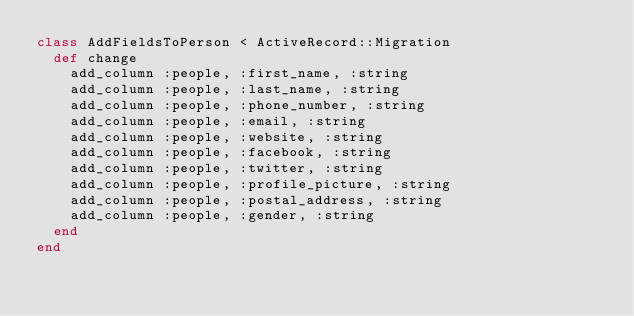<code> <loc_0><loc_0><loc_500><loc_500><_Ruby_>class AddFieldsToPerson < ActiveRecord::Migration
  def change
    add_column :people, :first_name, :string
    add_column :people, :last_name, :string
    add_column :people, :phone_number, :string
    add_column :people, :email, :string
    add_column :people, :website, :string
    add_column :people, :facebook, :string
    add_column :people, :twitter, :string
    add_column :people, :profile_picture, :string
    add_column :people, :postal_address, :string
    add_column :people, :gender, :string
  end
end
</code> 